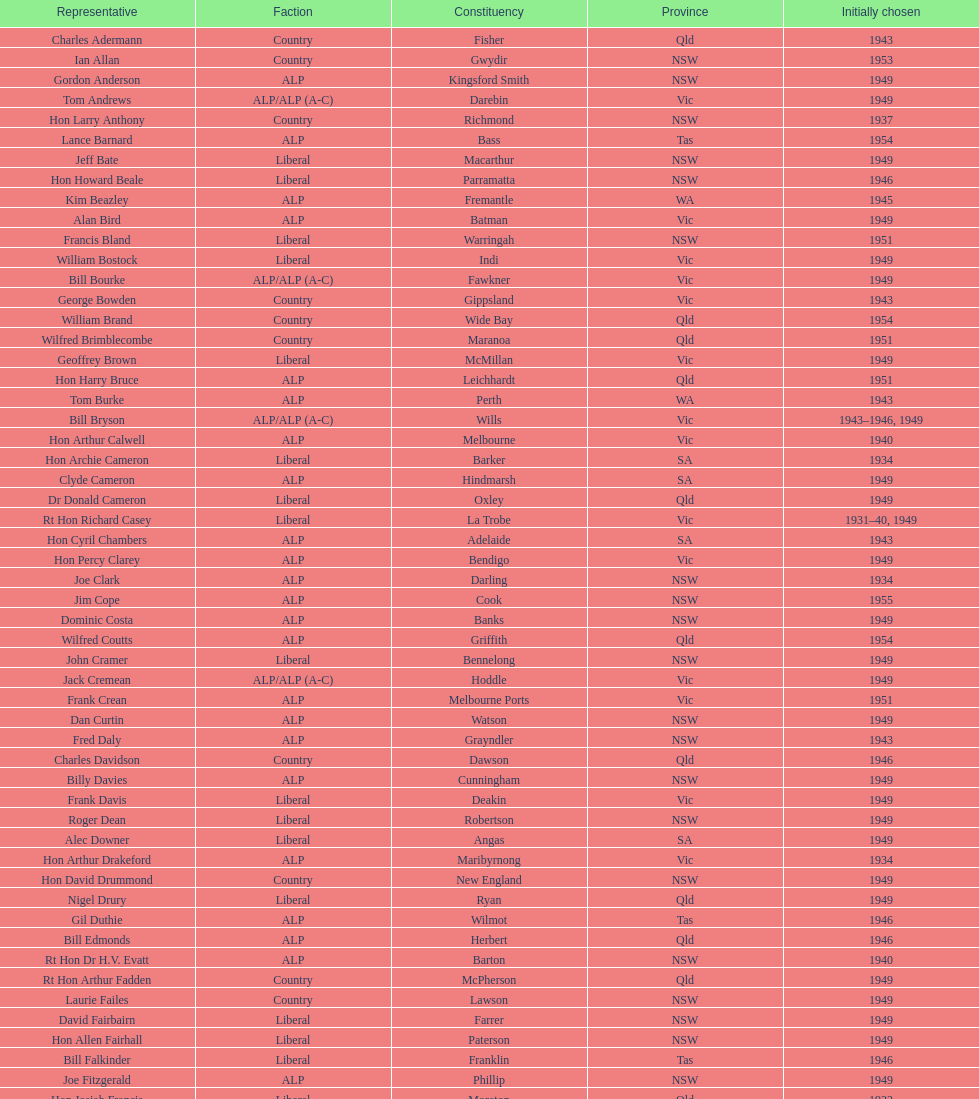When was joe clark first elected? 1934. 